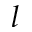<formula> <loc_0><loc_0><loc_500><loc_500>l</formula> 